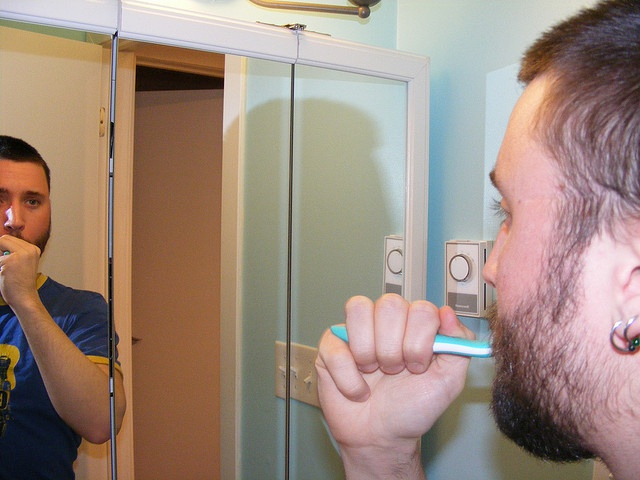Describe the objects in this image and their specific colors. I can see people in lightgray, lightpink, darkgray, and gray tones, people in lightgray, black, brown, and navy tones, and toothbrush in lightgray, lavender, lightblue, and teal tones in this image. 